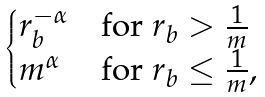Convert formula to latex. <formula><loc_0><loc_0><loc_500><loc_500>\begin{cases} r _ { b } ^ { - \alpha } & \text {for     $r_{b}>\frac{1}{m}$} \\ m ^ { \alpha } & \text {for $r_{b} \leq \frac{1}{m}$} , \end{cases}</formula> 